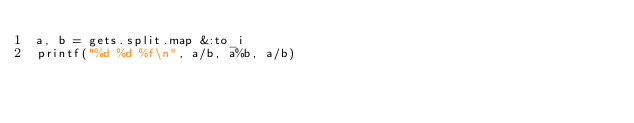<code> <loc_0><loc_0><loc_500><loc_500><_Ruby_>a, b = gets.split.map &:to_i
printf("%d %d %f\n", a/b, a%b, a/b)</code> 